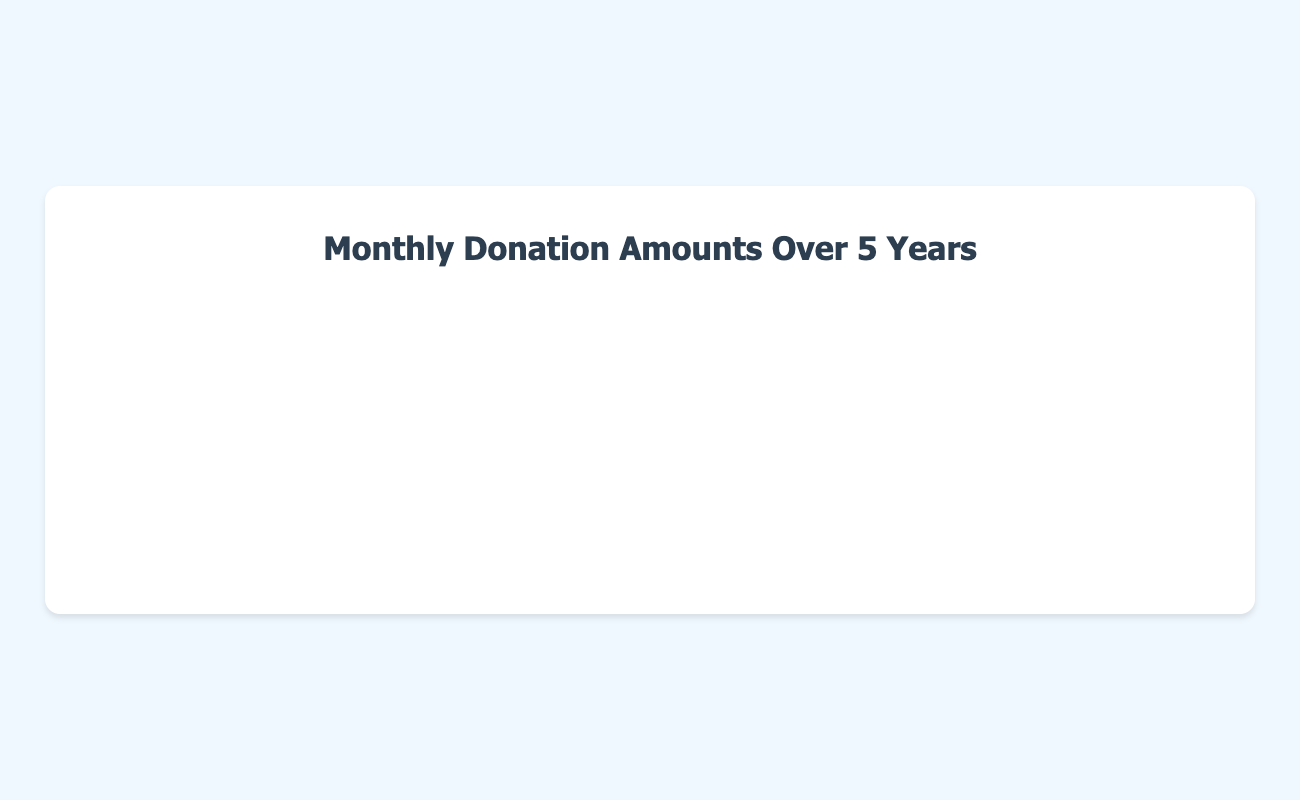How does the donation amount trend from January 2018 to December 2023? To answer this, one can observe the line plot and see that the donation amount shows a general upward trend from January 2018 to December 2023, with some fluctuations along the way. The line steadily increases as the months progress.
Answer: Upward trend Which month had the highest donation amount in 2020? By examining the plot and looking at the highest peak in the year 2020, we can see that October 2020 had the highest donation amount at $11,500.
Answer: October 2020 What is the difference in donation amounts between the highest and lowest months in 2019? First, identify the highest and lowest points in 2019. The highest donation amount was in December 2019 ($9,500), and the lowest was in February 2019 ($6,700). Subtract the lowest from the highest: 9500 - 6700 = 2800.
Answer: 2800 During which period did the donation amount increase the fastest? Observe the changes in the slope of the line. The period from January 2022 to December 2022 shows a steep increase in the donation amount. In January 2022, the donation amount was $18,500, and in December 2022, it was $23,800. This is an increase of $5,300 in 12 months.
Answer: January 2022 to December 2022 Is there a recurring pattern in donation amounts at the end of each year? By visually inspecting the plot, it is noticeable that there is a recurring spike in donation amounts at the end of each year, specifically in December. For example, December 2018 ($6,500), December 2019 ($9,500), and December 2020 ($12,500) all show higher donation amounts compared to earlier in the respective years.
Answer: Yes What was the donation amount in July 2023, and how does it compare to January 2023? First, locate the data points for July 2023 ($27,300) and January 2023 ($24,300) on the plot. The difference between them is $27,300 - $24,300 = $3,000.
Answer: July 2023 was higher by $3,000 Calculate the average monthly donation amount in 2021. Identify the donation amounts for each month in 2021 and calculate the average: (12800 + 13300 + 13800 + 14000 + 14500 + 15000 + 15500 + 16000 + 16500 + 17000 + 17500 + 18000) / 12 = 15100.
Answer: 15100 Compare the total donation amounts between the first half and the second half of 2022. Sum the donation amounts for January to June 2022: 18500 + 18800 + 19300 + 19800 + 20300 + 20800 = 117500. Sum the donation amounts for July to December 2022: 21300 + 21800 + 22300 + 22800 + 23300 + 23800 = 135300. Comparison: 117500 vs 135300.
Answer: Second half was higher by 17800 Identify any months where the donation amount did not increase from the previous month. By checking the plot for months without an increase:
- April 2020 (10500 to 9100)
- May 2020 (9100 to 9200)
- September 2020 (10300 to 10800)
- June 2023 (26300 to 26800)
Answer: April, May, September 2020 and June 2023 When did the donation amount first reach $10,000? Locate the point on the plot where the donation amount first hits $10,000. This is in January 2020.
Answer: January 2020 